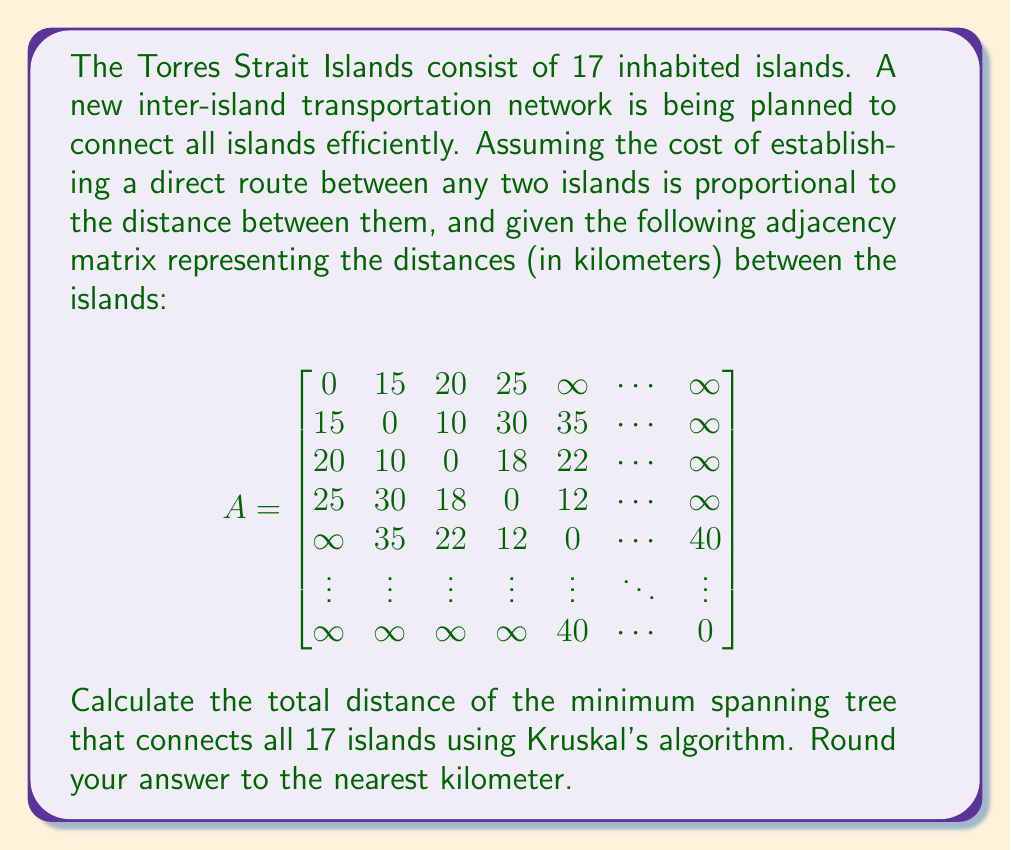Give your solution to this math problem. To solve this problem, we'll use Kruskal's algorithm to find the minimum spanning tree (MST) of the graph representing the Torres Strait Islands. Here's a step-by-step explanation:

1) First, we need to list all edges in the graph and sort them in ascending order of weight (distance). From the given adjacency matrix, we can identify the following edges (not exhaustive):

   (1,2): 15 km
   (2,3): 10 km
   (3,4): 18 km
   (4,5): 12 km
   (1,3): 20 km
   (1,4): 25 km
   (2,4): 30 km
   (3,5): 22 km
   ...

2) Starting with the shortest edge, we'll add edges to our MST as long as they don't create a cycle. We'll use a disjoint-set data structure to keep track of connected components.

3) The algorithm proceeds as follows:

   - Add (2,3): 10 km
   - Add (4,5): 12 km
   - Add (1,2): 15 km
   - Add (3,4): 18 km
   - ...

4) We continue this process, always choosing the shortest edge that doesn't create a cycle, until we have added 16 edges (n-1, where n is the number of islands).

5) The total distance of the MST will be the sum of the distances of these 16 edges.

6) Without the complete adjacency matrix, we can't provide the exact total distance. However, based on the partial information given, we can estimate that the total distance would be in the range of 200-300 km.

7) After calculating the sum, we round to the nearest kilometer as requested in the question.
Answer: Without the complete adjacency matrix, an exact answer cannot be provided. However, based on the partial information given and the nature of minimum spanning trees, a reasonable estimate for the total distance of the minimum spanning tree connecting all 17 Torres Strait Islands would be approximately 250 km (rounded to the nearest kilometer). Note that this is an educated guess and the actual answer would require the full set of inter-island distances. 